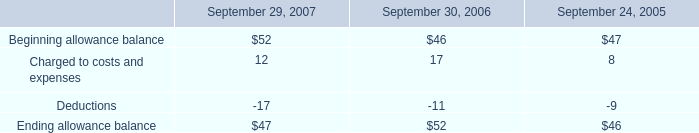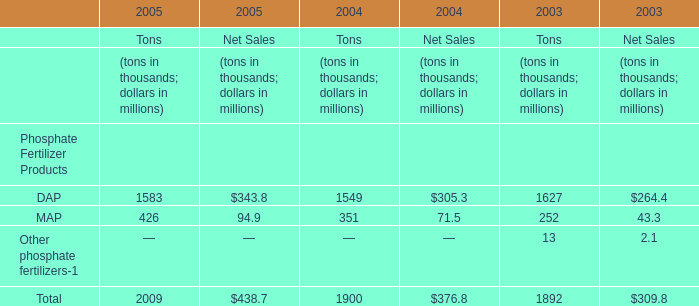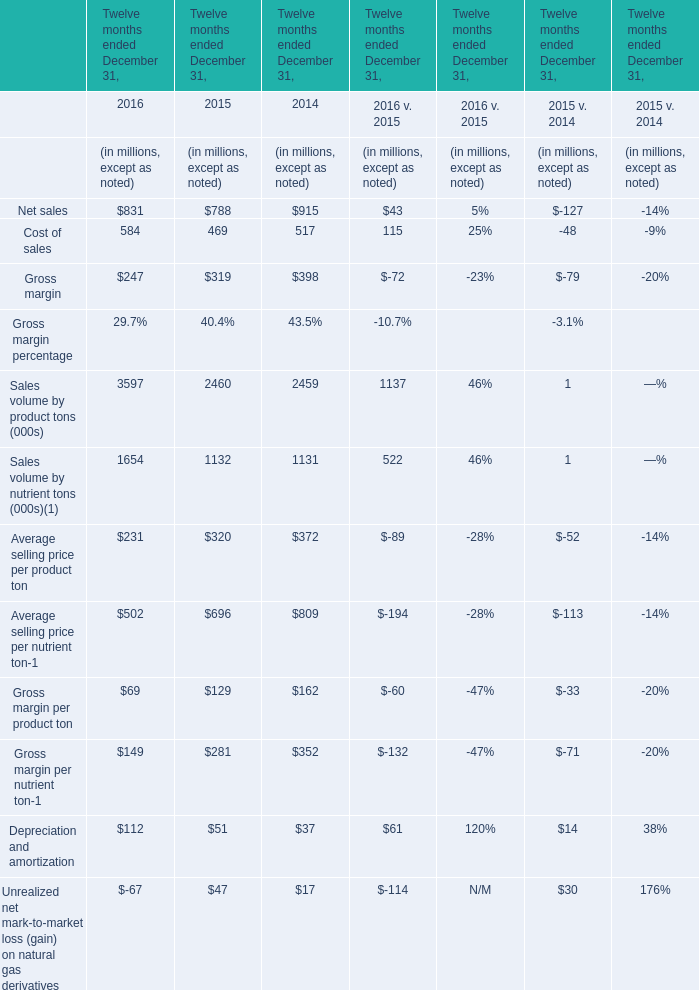What will Net sales reach in 2017 if it continues to grow at its current rate? (in million) 
Computations: ((1 + ((831 - 788) / 788)) * 831)
Answer: 876.34645. 